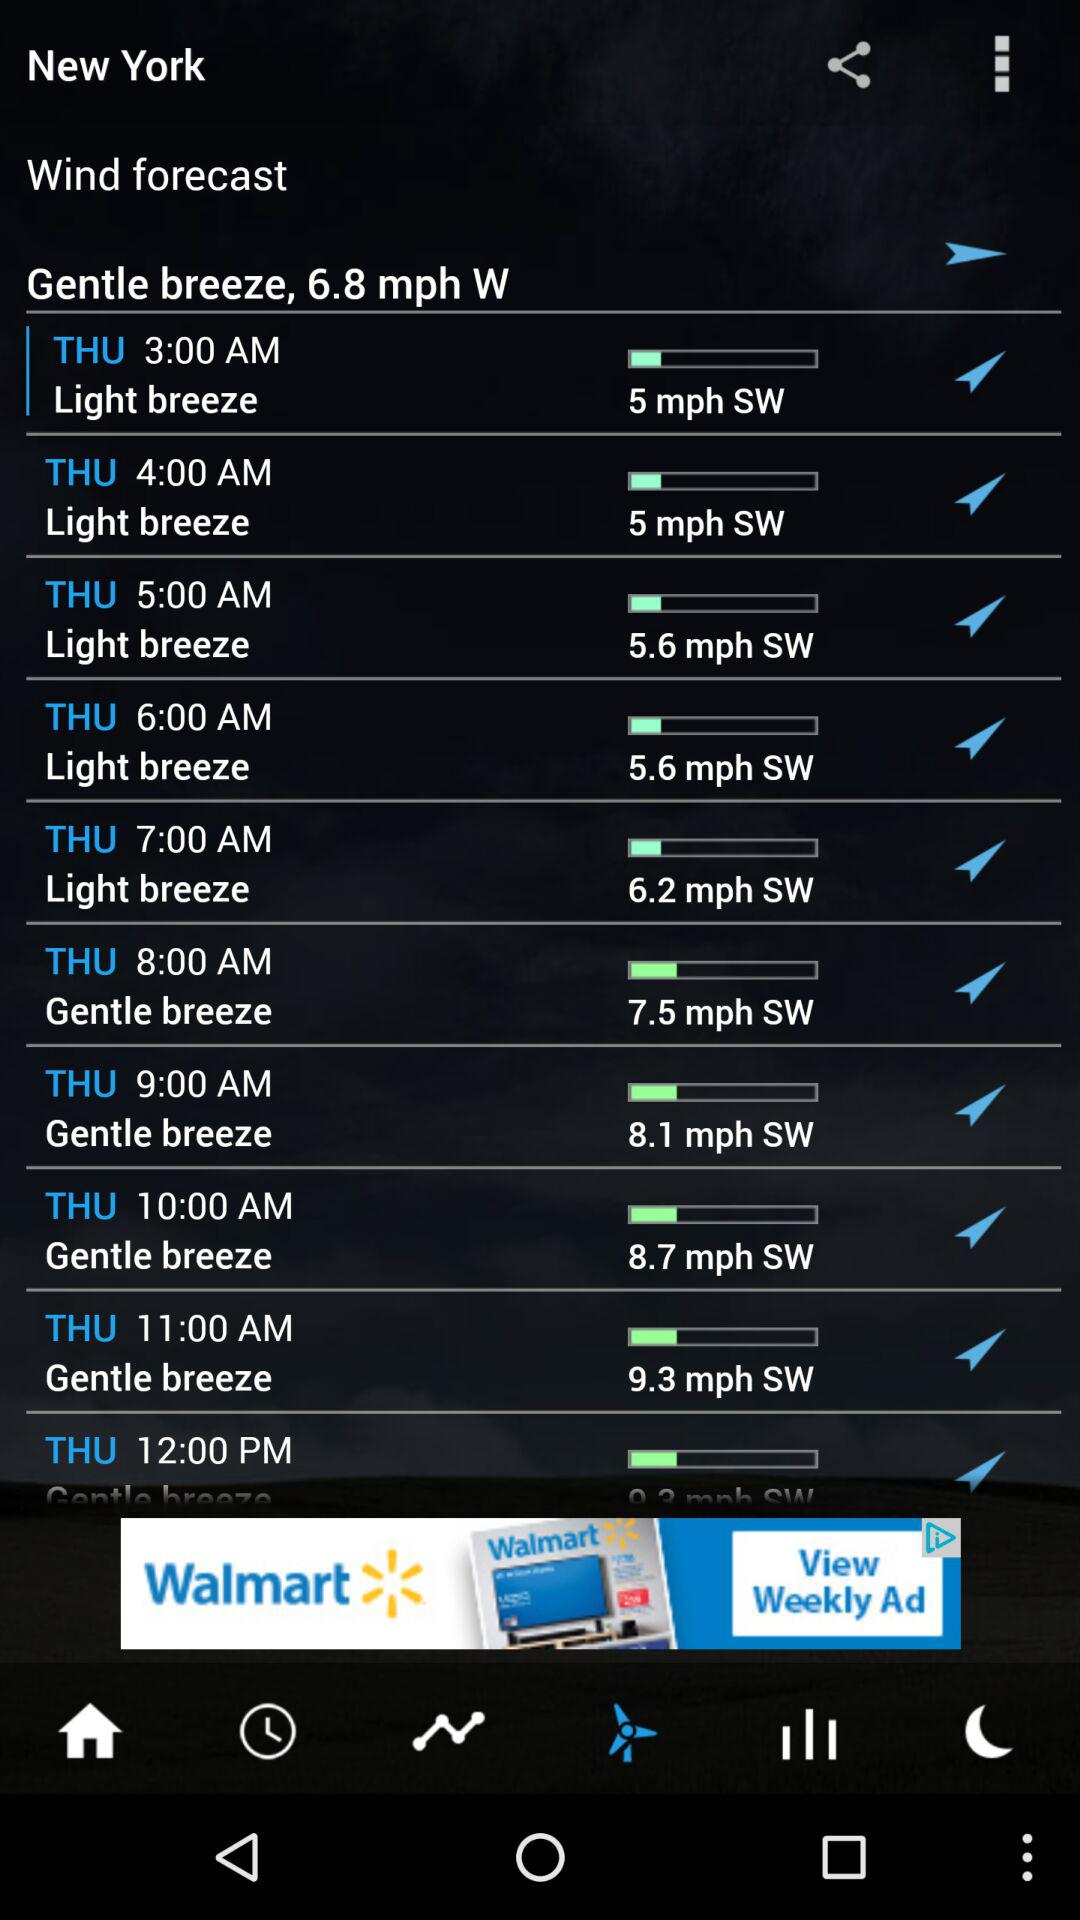How is the breeze going to be like on Thursday at 4 am? The breeze is going to be "Light". 